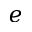Convert formula to latex. <formula><loc_0><loc_0><loc_500><loc_500>e</formula> 